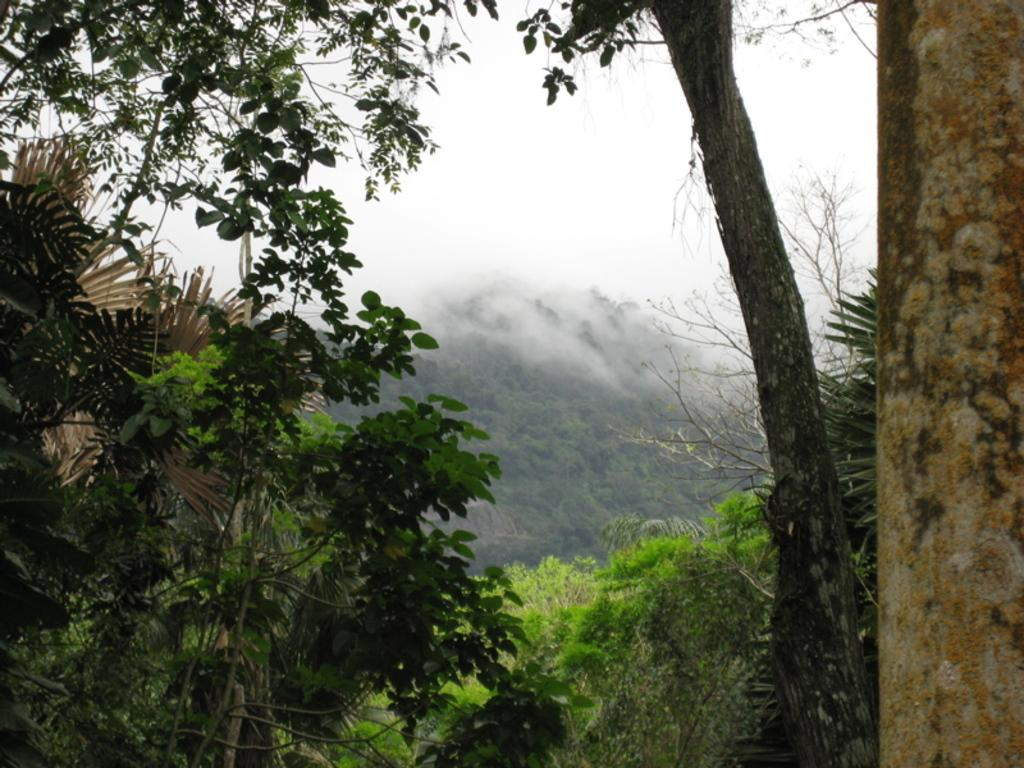What type of vegetation can be seen in the image? There are many trees, plants, and grass visible in the image. What is visible in the background of the image? There is fog and a mountain visible in the background of the image. What is the condition of the sky in the image? The sky is visible at the top of the image, and clouds are present. What type of disease is affecting the trees in the image? There is no indication of any disease affecting the trees in the image; they appear healthy. What is the sound of the alarm in the image? There is no alarm present in the image; it is a natural scene with no audible elements. 